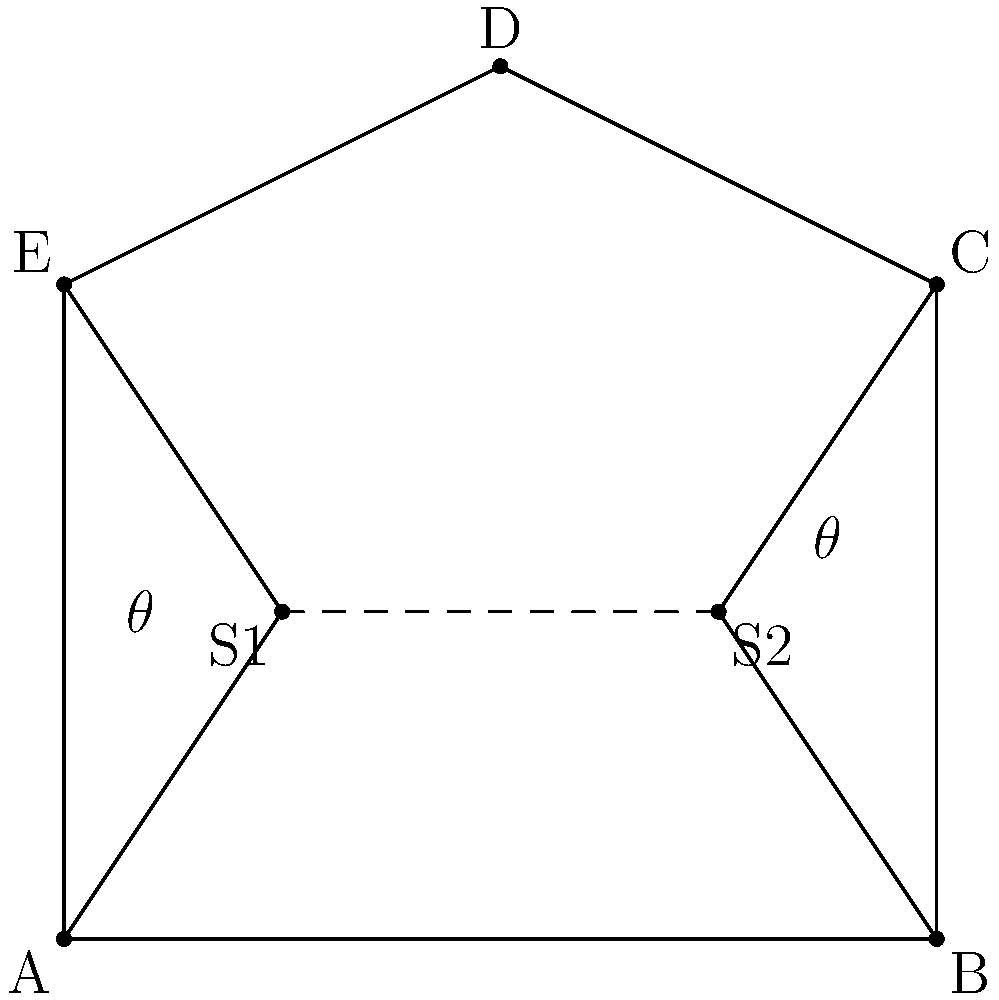In a pentagon-shaped event space, you need to position two speakers (S1 and S2) for optimal sound distribution. If the speakers are placed on the line connecting the midpoints of sides AE and BC, and the angle between each speaker and its adjacent corners is $\theta$, what should $\theta$ be to ensure even sound coverage? To find the optimal angle $\theta$ for even sound distribution, we'll follow these steps:

1. Recognize that for even sound distribution, we want the speakers to cover equal areas of the room.

2. The pentagon can be divided into three areas: the area covered by S1, the area covered by S2, and the overlapping area in the middle.

3. For optimal coverage, the angle $\theta$ should be such that:
   - S1 covers half of the pentagon (excluding the overlap)
   - S2 covers the other half (excluding the overlap)
   - The overlap area is minimized

4. In a regular pentagon, each internal angle is $(540^\circ / 5) = 108^\circ$.

5. To cover half of the pentagon (excluding overlap), each speaker should cover an angle of:
   $$(108^\circ \times 5) / 2 = 270^\circ$$

6. This means that the angle $\theta$ from each speaker to its adjacent corners should be:
   $$\theta = 270^\circ / 2 = 135^\circ$$

7. Alternatively, we can express this as an angle from the speaker line:
   $$135^\circ - 90^\circ = 45^\circ$$

Therefore, the optimal angle $\theta$ for even sound coverage is $135^\circ$ from the adjacent corners, or $45^\circ$ from the speaker line.
Answer: $135^\circ$ (or $45^\circ$ from the speaker line) 